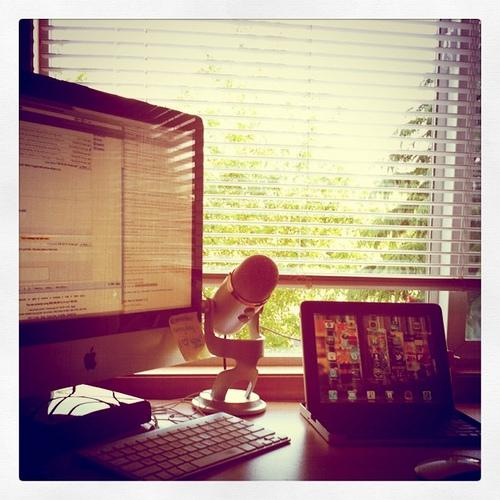Question: what is standing between the laptop and the desktop?
Choices:
A. A printer.
B. A scanner.
C. A fax machine.
D. A microphone.
Answer with the letter. Answer: D Question: what is seen through the window?
Choices:
A. Children.
B. Trees.
C. A dog.
D. Grass.
Answer with the letter. Answer: B Question: what color are the blinds?
Choices:
A. Black.
B. Brown.
C. Purple.
D. White.
Answer with the letter. Answer: D Question: who is using the computer?
Choices:
A. A man.
B. Nobody.
C. A woman.
D. A child.
Answer with the letter. Answer: B 